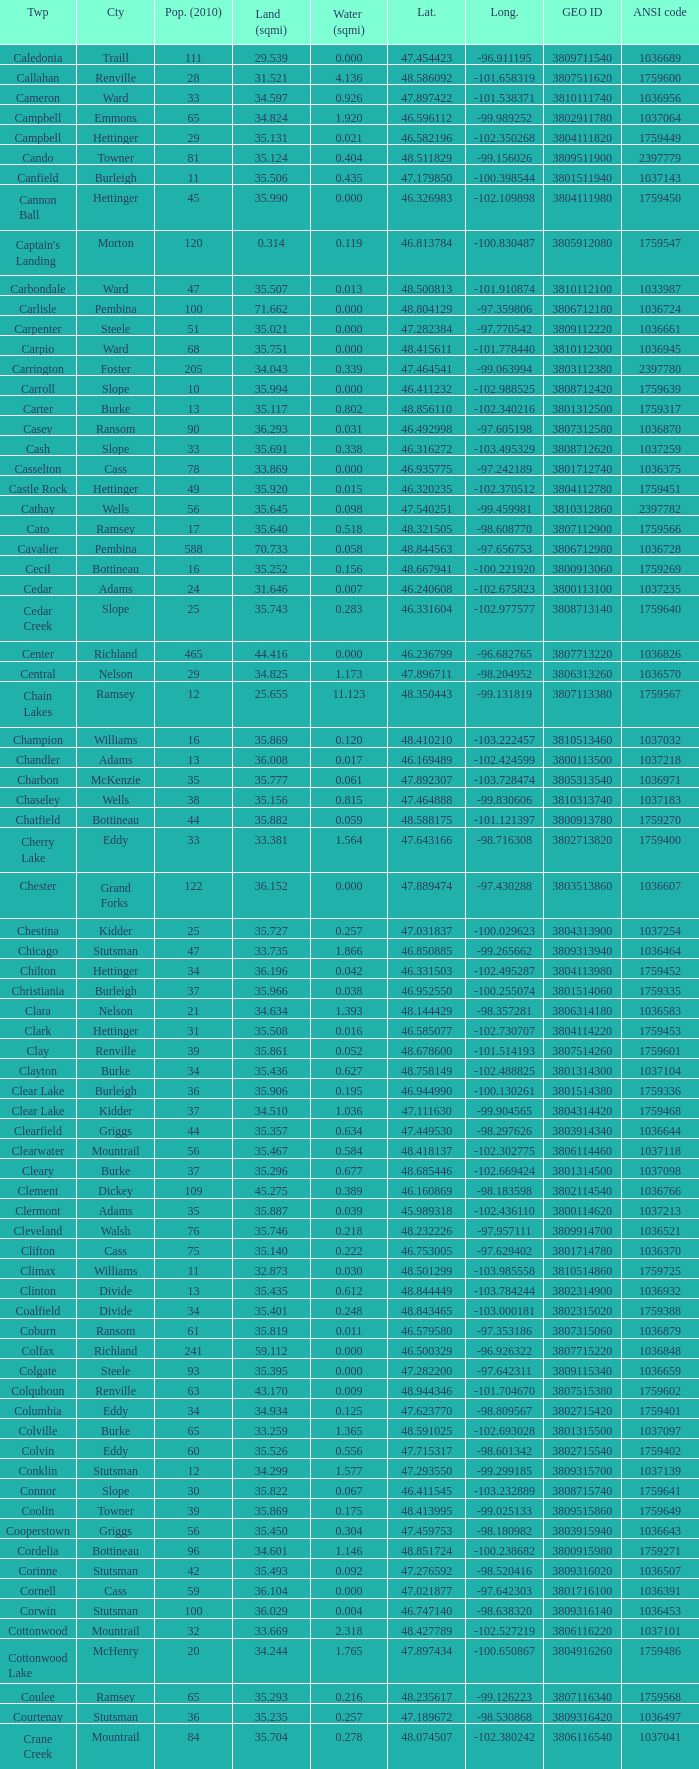What was the longitude of the township with a latitude of 48.075823? -98.857272. 